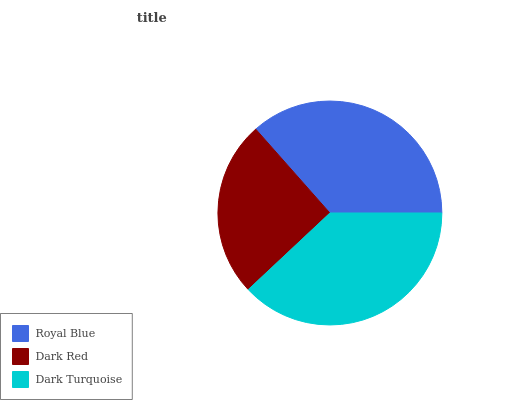Is Dark Red the minimum?
Answer yes or no. Yes. Is Dark Turquoise the maximum?
Answer yes or no. Yes. Is Dark Turquoise the minimum?
Answer yes or no. No. Is Dark Red the maximum?
Answer yes or no. No. Is Dark Turquoise greater than Dark Red?
Answer yes or no. Yes. Is Dark Red less than Dark Turquoise?
Answer yes or no. Yes. Is Dark Red greater than Dark Turquoise?
Answer yes or no. No. Is Dark Turquoise less than Dark Red?
Answer yes or no. No. Is Royal Blue the high median?
Answer yes or no. Yes. Is Royal Blue the low median?
Answer yes or no. Yes. Is Dark Turquoise the high median?
Answer yes or no. No. Is Dark Turquoise the low median?
Answer yes or no. No. 